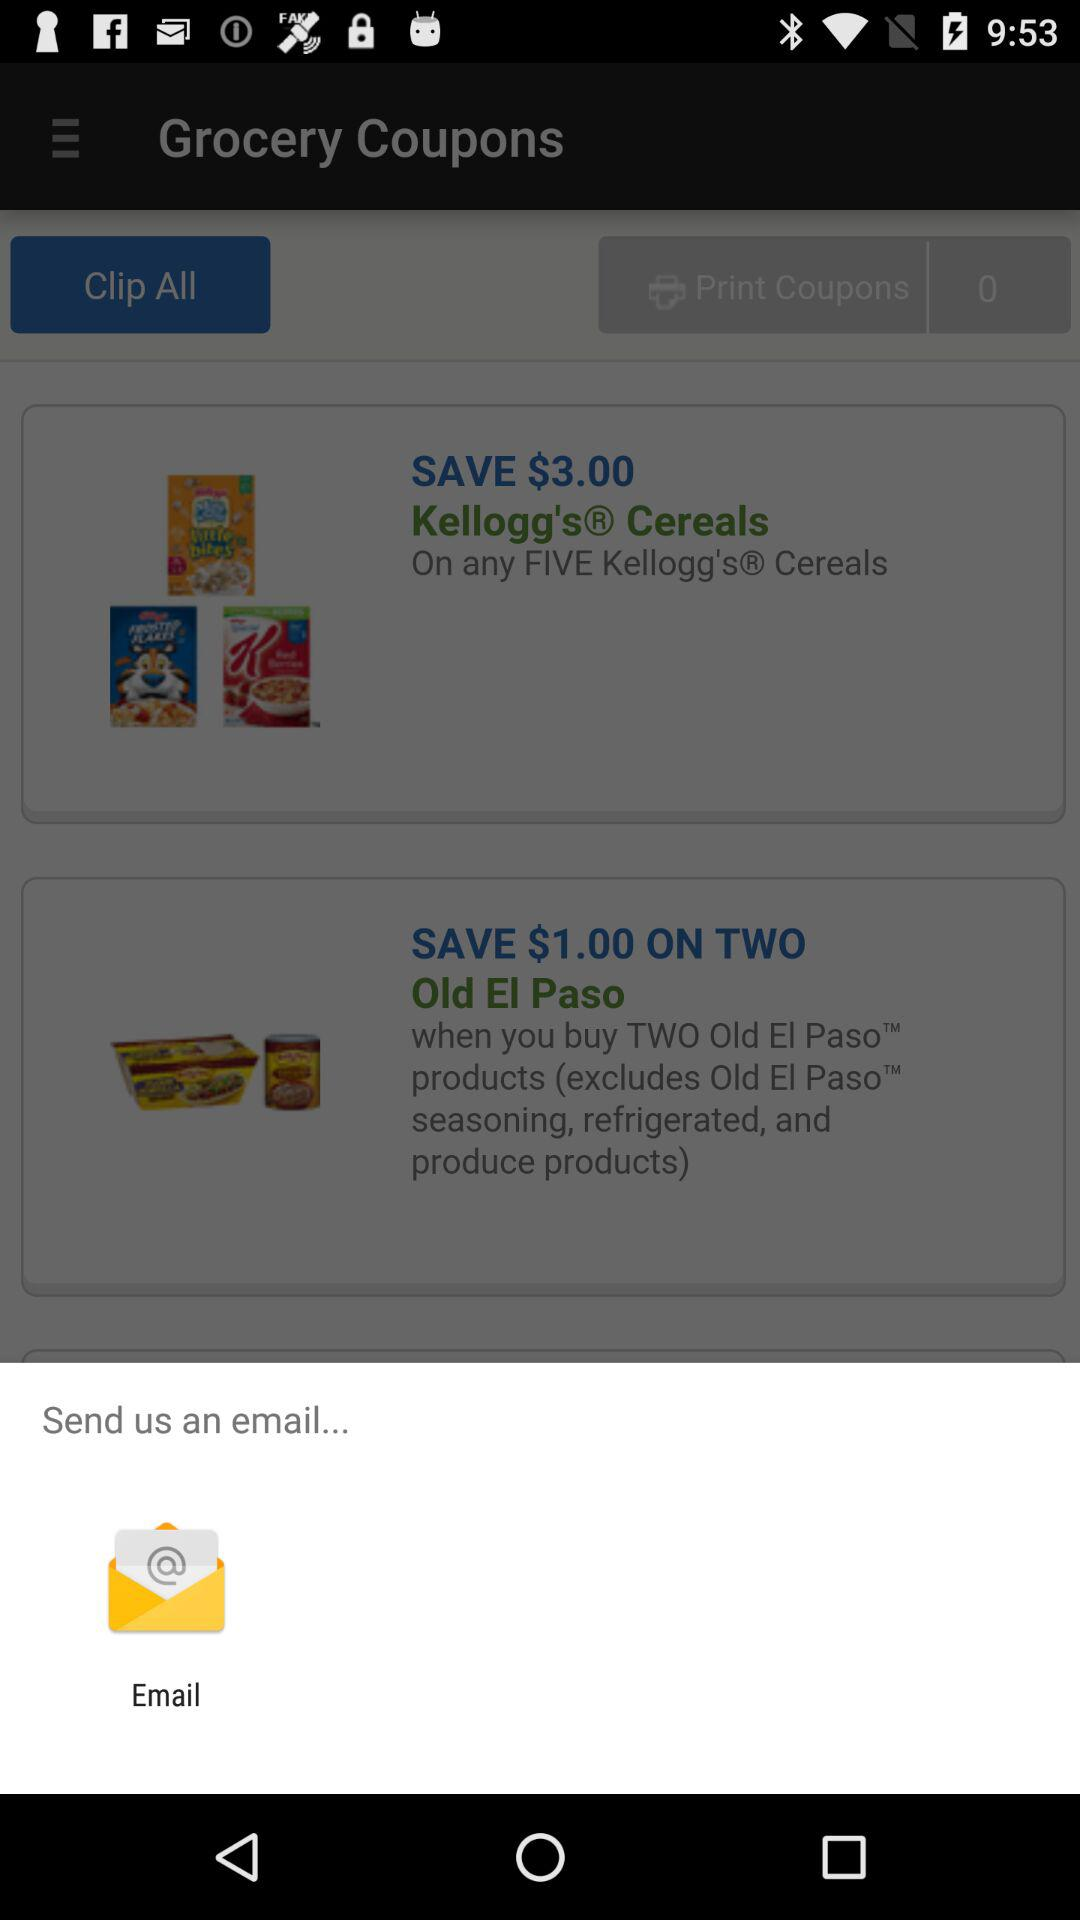What option is given for email? The option is "Email". 